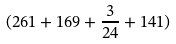Convert formula to latex. <formula><loc_0><loc_0><loc_500><loc_500>( 2 6 1 + 1 6 9 + \frac { 3 } { 2 4 } + 1 4 1 )</formula> 